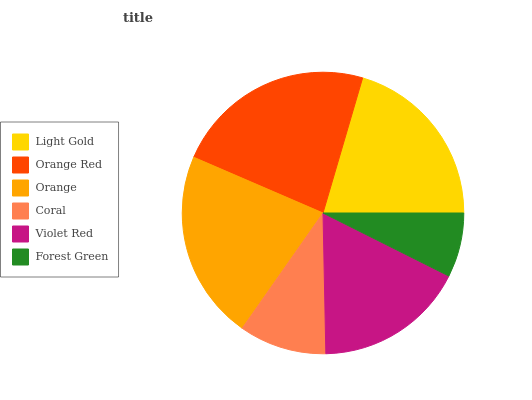Is Forest Green the minimum?
Answer yes or no. Yes. Is Orange Red the maximum?
Answer yes or no. Yes. Is Orange the minimum?
Answer yes or no. No. Is Orange the maximum?
Answer yes or no. No. Is Orange Red greater than Orange?
Answer yes or no. Yes. Is Orange less than Orange Red?
Answer yes or no. Yes. Is Orange greater than Orange Red?
Answer yes or no. No. Is Orange Red less than Orange?
Answer yes or no. No. Is Light Gold the high median?
Answer yes or no. Yes. Is Violet Red the low median?
Answer yes or no. Yes. Is Orange Red the high median?
Answer yes or no. No. Is Orange the low median?
Answer yes or no. No. 